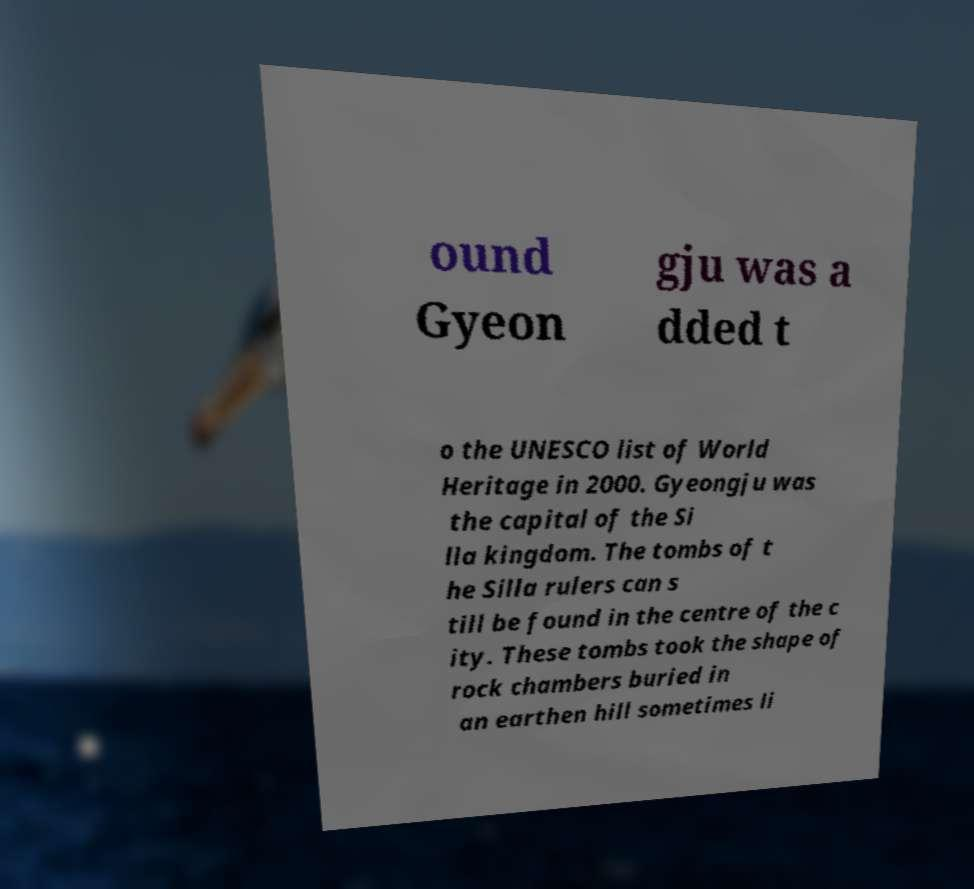For documentation purposes, I need the text within this image transcribed. Could you provide that? ound Gyeon gju was a dded t o the UNESCO list of World Heritage in 2000. Gyeongju was the capital of the Si lla kingdom. The tombs of t he Silla rulers can s till be found in the centre of the c ity. These tombs took the shape of rock chambers buried in an earthen hill sometimes li 